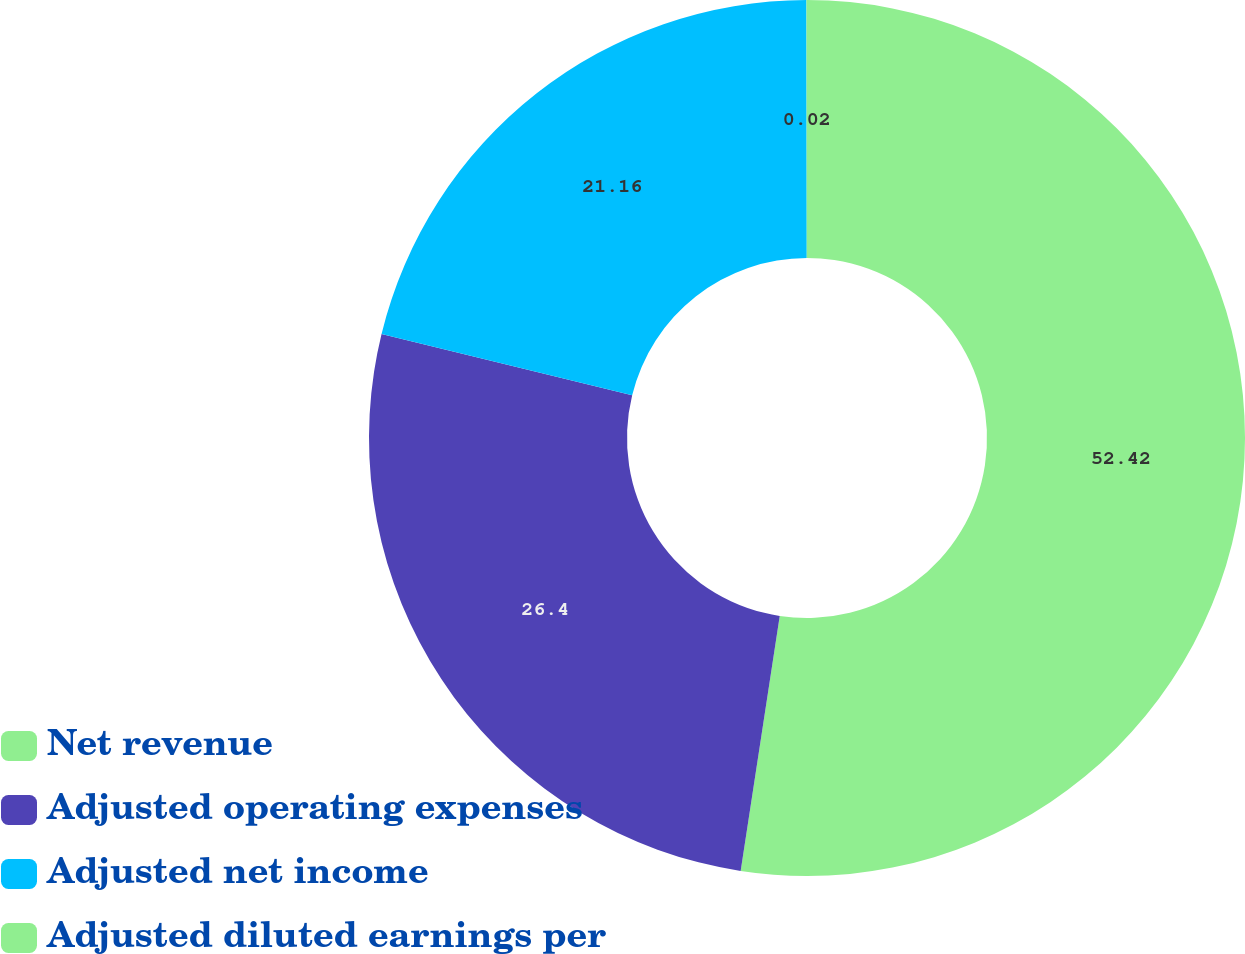<chart> <loc_0><loc_0><loc_500><loc_500><pie_chart><fcel>Net revenue<fcel>Adjusted operating expenses<fcel>Adjusted net income<fcel>Adjusted diluted earnings per<nl><fcel>52.42%<fcel>26.4%<fcel>21.16%<fcel>0.02%<nl></chart> 